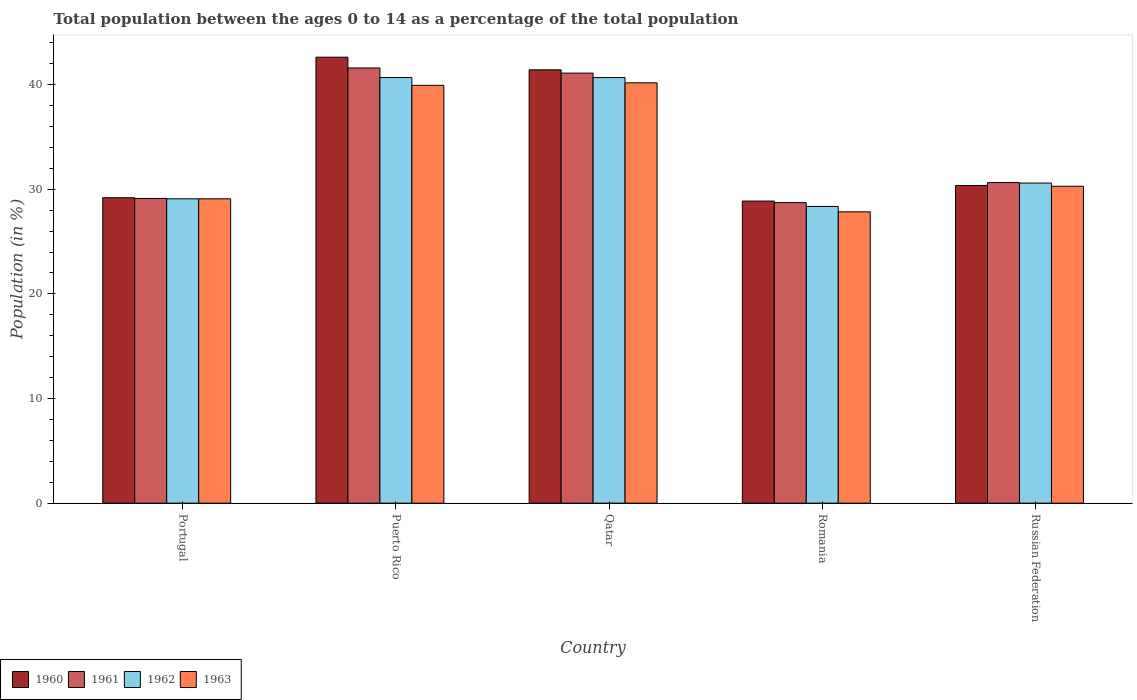How many different coloured bars are there?
Make the answer very short. 4. How many groups of bars are there?
Give a very brief answer. 5. Are the number of bars per tick equal to the number of legend labels?
Offer a very short reply. Yes. Are the number of bars on each tick of the X-axis equal?
Your answer should be very brief. Yes. What is the label of the 3rd group of bars from the left?
Keep it short and to the point. Qatar. In how many cases, is the number of bars for a given country not equal to the number of legend labels?
Offer a terse response. 0. What is the percentage of the population ages 0 to 14 in 1963 in Portugal?
Your answer should be compact. 29.09. Across all countries, what is the maximum percentage of the population ages 0 to 14 in 1961?
Your answer should be compact. 41.6. Across all countries, what is the minimum percentage of the population ages 0 to 14 in 1962?
Your response must be concise. 28.36. In which country was the percentage of the population ages 0 to 14 in 1960 maximum?
Offer a very short reply. Puerto Rico. In which country was the percentage of the population ages 0 to 14 in 1960 minimum?
Provide a short and direct response. Romania. What is the total percentage of the population ages 0 to 14 in 1963 in the graph?
Give a very brief answer. 167.35. What is the difference between the percentage of the population ages 0 to 14 in 1961 in Qatar and that in Romania?
Offer a very short reply. 12.38. What is the difference between the percentage of the population ages 0 to 14 in 1960 in Puerto Rico and the percentage of the population ages 0 to 14 in 1963 in Russian Federation?
Offer a very short reply. 12.34. What is the average percentage of the population ages 0 to 14 in 1961 per country?
Your answer should be very brief. 34.24. What is the difference between the percentage of the population ages 0 to 14 of/in 1963 and percentage of the population ages 0 to 14 of/in 1962 in Romania?
Provide a succinct answer. -0.51. In how many countries, is the percentage of the population ages 0 to 14 in 1963 greater than 28?
Ensure brevity in your answer.  4. What is the ratio of the percentage of the population ages 0 to 14 in 1961 in Puerto Rico to that in Russian Federation?
Ensure brevity in your answer.  1.36. Is the percentage of the population ages 0 to 14 in 1961 in Puerto Rico less than that in Russian Federation?
Your answer should be compact. No. Is the difference between the percentage of the population ages 0 to 14 in 1963 in Portugal and Qatar greater than the difference between the percentage of the population ages 0 to 14 in 1962 in Portugal and Qatar?
Provide a succinct answer. Yes. What is the difference between the highest and the second highest percentage of the population ages 0 to 14 in 1963?
Make the answer very short. 9.89. What is the difference between the highest and the lowest percentage of the population ages 0 to 14 in 1960?
Keep it short and to the point. 13.76. In how many countries, is the percentage of the population ages 0 to 14 in 1962 greater than the average percentage of the population ages 0 to 14 in 1962 taken over all countries?
Make the answer very short. 2. Is it the case that in every country, the sum of the percentage of the population ages 0 to 14 in 1960 and percentage of the population ages 0 to 14 in 1962 is greater than the sum of percentage of the population ages 0 to 14 in 1961 and percentage of the population ages 0 to 14 in 1963?
Your response must be concise. No. What does the 1st bar from the left in Portugal represents?
Your answer should be very brief. 1960. What does the 3rd bar from the right in Romania represents?
Offer a very short reply. 1961. Is it the case that in every country, the sum of the percentage of the population ages 0 to 14 in 1962 and percentage of the population ages 0 to 14 in 1963 is greater than the percentage of the population ages 0 to 14 in 1961?
Provide a short and direct response. Yes. Are all the bars in the graph horizontal?
Keep it short and to the point. No. How many countries are there in the graph?
Your answer should be very brief. 5. Does the graph contain any zero values?
Your answer should be very brief. No. Does the graph contain grids?
Your answer should be very brief. No. Where does the legend appear in the graph?
Your answer should be compact. Bottom left. How are the legend labels stacked?
Make the answer very short. Horizontal. What is the title of the graph?
Make the answer very short. Total population between the ages 0 to 14 as a percentage of the total population. Does "1982" appear as one of the legend labels in the graph?
Offer a very short reply. No. What is the label or title of the Y-axis?
Ensure brevity in your answer.  Population (in %). What is the Population (in %) in 1960 in Portugal?
Offer a very short reply. 29.19. What is the Population (in %) in 1961 in Portugal?
Give a very brief answer. 29.13. What is the Population (in %) in 1962 in Portugal?
Keep it short and to the point. 29.09. What is the Population (in %) of 1963 in Portugal?
Provide a short and direct response. 29.09. What is the Population (in %) of 1960 in Puerto Rico?
Your answer should be very brief. 42.63. What is the Population (in %) of 1961 in Puerto Rico?
Your response must be concise. 41.6. What is the Population (in %) of 1962 in Puerto Rico?
Offer a terse response. 40.69. What is the Population (in %) in 1963 in Puerto Rico?
Your answer should be very brief. 39.94. What is the Population (in %) of 1960 in Qatar?
Make the answer very short. 41.42. What is the Population (in %) in 1961 in Qatar?
Provide a succinct answer. 41.11. What is the Population (in %) of 1962 in Qatar?
Make the answer very short. 40.68. What is the Population (in %) of 1963 in Qatar?
Make the answer very short. 40.18. What is the Population (in %) in 1960 in Romania?
Offer a very short reply. 28.88. What is the Population (in %) of 1961 in Romania?
Offer a very short reply. 28.73. What is the Population (in %) in 1962 in Romania?
Your answer should be compact. 28.36. What is the Population (in %) in 1963 in Romania?
Your answer should be compact. 27.85. What is the Population (in %) of 1960 in Russian Federation?
Give a very brief answer. 30.37. What is the Population (in %) of 1961 in Russian Federation?
Your response must be concise. 30.64. What is the Population (in %) in 1962 in Russian Federation?
Keep it short and to the point. 30.6. What is the Population (in %) in 1963 in Russian Federation?
Provide a succinct answer. 30.29. Across all countries, what is the maximum Population (in %) in 1960?
Offer a terse response. 42.63. Across all countries, what is the maximum Population (in %) of 1961?
Your answer should be compact. 41.6. Across all countries, what is the maximum Population (in %) in 1962?
Give a very brief answer. 40.69. Across all countries, what is the maximum Population (in %) in 1963?
Your answer should be compact. 40.18. Across all countries, what is the minimum Population (in %) of 1960?
Keep it short and to the point. 28.88. Across all countries, what is the minimum Population (in %) of 1961?
Ensure brevity in your answer.  28.73. Across all countries, what is the minimum Population (in %) in 1962?
Provide a short and direct response. 28.36. Across all countries, what is the minimum Population (in %) in 1963?
Ensure brevity in your answer.  27.85. What is the total Population (in %) of 1960 in the graph?
Make the answer very short. 172.48. What is the total Population (in %) of 1961 in the graph?
Your response must be concise. 171.2. What is the total Population (in %) in 1962 in the graph?
Give a very brief answer. 169.42. What is the total Population (in %) of 1963 in the graph?
Provide a succinct answer. 167.35. What is the difference between the Population (in %) in 1960 in Portugal and that in Puerto Rico?
Your answer should be very brief. -13.44. What is the difference between the Population (in %) in 1961 in Portugal and that in Puerto Rico?
Your answer should be compact. -12.47. What is the difference between the Population (in %) of 1962 in Portugal and that in Puerto Rico?
Your response must be concise. -11.59. What is the difference between the Population (in %) in 1963 in Portugal and that in Puerto Rico?
Offer a terse response. -10.85. What is the difference between the Population (in %) of 1960 in Portugal and that in Qatar?
Your response must be concise. -12.23. What is the difference between the Population (in %) in 1961 in Portugal and that in Qatar?
Make the answer very short. -11.98. What is the difference between the Population (in %) of 1962 in Portugal and that in Qatar?
Your response must be concise. -11.59. What is the difference between the Population (in %) of 1963 in Portugal and that in Qatar?
Your response must be concise. -11.09. What is the difference between the Population (in %) in 1960 in Portugal and that in Romania?
Your response must be concise. 0.32. What is the difference between the Population (in %) in 1961 in Portugal and that in Romania?
Provide a short and direct response. 0.4. What is the difference between the Population (in %) of 1962 in Portugal and that in Romania?
Your answer should be compact. 0.73. What is the difference between the Population (in %) of 1963 in Portugal and that in Romania?
Your answer should be very brief. 1.25. What is the difference between the Population (in %) in 1960 in Portugal and that in Russian Federation?
Your answer should be very brief. -1.17. What is the difference between the Population (in %) of 1961 in Portugal and that in Russian Federation?
Offer a terse response. -1.52. What is the difference between the Population (in %) in 1962 in Portugal and that in Russian Federation?
Make the answer very short. -1.5. What is the difference between the Population (in %) in 1963 in Portugal and that in Russian Federation?
Provide a short and direct response. -1.2. What is the difference between the Population (in %) of 1960 in Puerto Rico and that in Qatar?
Your answer should be compact. 1.21. What is the difference between the Population (in %) of 1961 in Puerto Rico and that in Qatar?
Keep it short and to the point. 0.49. What is the difference between the Population (in %) in 1962 in Puerto Rico and that in Qatar?
Your response must be concise. 0.01. What is the difference between the Population (in %) in 1963 in Puerto Rico and that in Qatar?
Offer a very short reply. -0.24. What is the difference between the Population (in %) of 1960 in Puerto Rico and that in Romania?
Keep it short and to the point. 13.76. What is the difference between the Population (in %) of 1961 in Puerto Rico and that in Romania?
Your response must be concise. 12.87. What is the difference between the Population (in %) of 1962 in Puerto Rico and that in Romania?
Provide a short and direct response. 12.33. What is the difference between the Population (in %) of 1963 in Puerto Rico and that in Romania?
Your response must be concise. 12.09. What is the difference between the Population (in %) in 1960 in Puerto Rico and that in Russian Federation?
Your response must be concise. 12.26. What is the difference between the Population (in %) of 1961 in Puerto Rico and that in Russian Federation?
Keep it short and to the point. 10.96. What is the difference between the Population (in %) of 1962 in Puerto Rico and that in Russian Federation?
Provide a short and direct response. 10.09. What is the difference between the Population (in %) of 1963 in Puerto Rico and that in Russian Federation?
Make the answer very short. 9.65. What is the difference between the Population (in %) in 1960 in Qatar and that in Romania?
Offer a terse response. 12.54. What is the difference between the Population (in %) of 1961 in Qatar and that in Romania?
Offer a terse response. 12.38. What is the difference between the Population (in %) of 1962 in Qatar and that in Romania?
Provide a short and direct response. 12.32. What is the difference between the Population (in %) of 1963 in Qatar and that in Romania?
Give a very brief answer. 12.33. What is the difference between the Population (in %) in 1960 in Qatar and that in Russian Federation?
Give a very brief answer. 11.05. What is the difference between the Population (in %) in 1961 in Qatar and that in Russian Federation?
Provide a succinct answer. 10.46. What is the difference between the Population (in %) of 1962 in Qatar and that in Russian Federation?
Ensure brevity in your answer.  10.09. What is the difference between the Population (in %) in 1963 in Qatar and that in Russian Federation?
Make the answer very short. 9.89. What is the difference between the Population (in %) in 1960 in Romania and that in Russian Federation?
Keep it short and to the point. -1.49. What is the difference between the Population (in %) of 1961 in Romania and that in Russian Federation?
Your response must be concise. -1.92. What is the difference between the Population (in %) in 1962 in Romania and that in Russian Federation?
Your answer should be very brief. -2.24. What is the difference between the Population (in %) of 1963 in Romania and that in Russian Federation?
Your answer should be very brief. -2.44. What is the difference between the Population (in %) in 1960 in Portugal and the Population (in %) in 1961 in Puerto Rico?
Provide a succinct answer. -12.41. What is the difference between the Population (in %) in 1960 in Portugal and the Population (in %) in 1962 in Puerto Rico?
Keep it short and to the point. -11.5. What is the difference between the Population (in %) of 1960 in Portugal and the Population (in %) of 1963 in Puerto Rico?
Your response must be concise. -10.75. What is the difference between the Population (in %) in 1961 in Portugal and the Population (in %) in 1962 in Puerto Rico?
Provide a succinct answer. -11.56. What is the difference between the Population (in %) in 1961 in Portugal and the Population (in %) in 1963 in Puerto Rico?
Provide a succinct answer. -10.81. What is the difference between the Population (in %) of 1962 in Portugal and the Population (in %) of 1963 in Puerto Rico?
Keep it short and to the point. -10.85. What is the difference between the Population (in %) in 1960 in Portugal and the Population (in %) in 1961 in Qatar?
Give a very brief answer. -11.91. What is the difference between the Population (in %) in 1960 in Portugal and the Population (in %) in 1962 in Qatar?
Offer a very short reply. -11.49. What is the difference between the Population (in %) in 1960 in Portugal and the Population (in %) in 1963 in Qatar?
Your response must be concise. -10.99. What is the difference between the Population (in %) in 1961 in Portugal and the Population (in %) in 1962 in Qatar?
Your answer should be very brief. -11.56. What is the difference between the Population (in %) in 1961 in Portugal and the Population (in %) in 1963 in Qatar?
Provide a succinct answer. -11.05. What is the difference between the Population (in %) of 1962 in Portugal and the Population (in %) of 1963 in Qatar?
Provide a short and direct response. -11.09. What is the difference between the Population (in %) in 1960 in Portugal and the Population (in %) in 1961 in Romania?
Offer a terse response. 0.47. What is the difference between the Population (in %) of 1960 in Portugal and the Population (in %) of 1962 in Romania?
Provide a succinct answer. 0.83. What is the difference between the Population (in %) of 1960 in Portugal and the Population (in %) of 1963 in Romania?
Provide a succinct answer. 1.34. What is the difference between the Population (in %) of 1961 in Portugal and the Population (in %) of 1962 in Romania?
Your answer should be compact. 0.76. What is the difference between the Population (in %) in 1961 in Portugal and the Population (in %) in 1963 in Romania?
Provide a succinct answer. 1.28. What is the difference between the Population (in %) of 1962 in Portugal and the Population (in %) of 1963 in Romania?
Your answer should be very brief. 1.25. What is the difference between the Population (in %) of 1960 in Portugal and the Population (in %) of 1961 in Russian Federation?
Offer a very short reply. -1.45. What is the difference between the Population (in %) in 1960 in Portugal and the Population (in %) in 1962 in Russian Federation?
Ensure brevity in your answer.  -1.4. What is the difference between the Population (in %) in 1960 in Portugal and the Population (in %) in 1963 in Russian Federation?
Your response must be concise. -1.1. What is the difference between the Population (in %) in 1961 in Portugal and the Population (in %) in 1962 in Russian Federation?
Your answer should be compact. -1.47. What is the difference between the Population (in %) of 1961 in Portugal and the Population (in %) of 1963 in Russian Federation?
Ensure brevity in your answer.  -1.17. What is the difference between the Population (in %) in 1962 in Portugal and the Population (in %) in 1963 in Russian Federation?
Make the answer very short. -1.2. What is the difference between the Population (in %) in 1960 in Puerto Rico and the Population (in %) in 1961 in Qatar?
Give a very brief answer. 1.52. What is the difference between the Population (in %) of 1960 in Puerto Rico and the Population (in %) of 1962 in Qatar?
Provide a succinct answer. 1.95. What is the difference between the Population (in %) of 1960 in Puerto Rico and the Population (in %) of 1963 in Qatar?
Ensure brevity in your answer.  2.45. What is the difference between the Population (in %) in 1961 in Puerto Rico and the Population (in %) in 1962 in Qatar?
Give a very brief answer. 0.92. What is the difference between the Population (in %) in 1961 in Puerto Rico and the Population (in %) in 1963 in Qatar?
Provide a short and direct response. 1.42. What is the difference between the Population (in %) of 1962 in Puerto Rico and the Population (in %) of 1963 in Qatar?
Keep it short and to the point. 0.51. What is the difference between the Population (in %) in 1960 in Puerto Rico and the Population (in %) in 1961 in Romania?
Offer a terse response. 13.9. What is the difference between the Population (in %) in 1960 in Puerto Rico and the Population (in %) in 1962 in Romania?
Keep it short and to the point. 14.27. What is the difference between the Population (in %) of 1960 in Puerto Rico and the Population (in %) of 1963 in Romania?
Provide a succinct answer. 14.78. What is the difference between the Population (in %) in 1961 in Puerto Rico and the Population (in %) in 1962 in Romania?
Your response must be concise. 13.24. What is the difference between the Population (in %) of 1961 in Puerto Rico and the Population (in %) of 1963 in Romania?
Your response must be concise. 13.75. What is the difference between the Population (in %) in 1962 in Puerto Rico and the Population (in %) in 1963 in Romania?
Keep it short and to the point. 12.84. What is the difference between the Population (in %) of 1960 in Puerto Rico and the Population (in %) of 1961 in Russian Federation?
Your response must be concise. 11.99. What is the difference between the Population (in %) in 1960 in Puerto Rico and the Population (in %) in 1962 in Russian Federation?
Provide a short and direct response. 12.03. What is the difference between the Population (in %) of 1960 in Puerto Rico and the Population (in %) of 1963 in Russian Federation?
Make the answer very short. 12.34. What is the difference between the Population (in %) in 1961 in Puerto Rico and the Population (in %) in 1962 in Russian Federation?
Offer a very short reply. 11. What is the difference between the Population (in %) of 1961 in Puerto Rico and the Population (in %) of 1963 in Russian Federation?
Provide a short and direct response. 11.31. What is the difference between the Population (in %) in 1962 in Puerto Rico and the Population (in %) in 1963 in Russian Federation?
Offer a very short reply. 10.4. What is the difference between the Population (in %) in 1960 in Qatar and the Population (in %) in 1961 in Romania?
Provide a succinct answer. 12.69. What is the difference between the Population (in %) in 1960 in Qatar and the Population (in %) in 1962 in Romania?
Your answer should be very brief. 13.06. What is the difference between the Population (in %) of 1960 in Qatar and the Population (in %) of 1963 in Romania?
Offer a very short reply. 13.57. What is the difference between the Population (in %) in 1961 in Qatar and the Population (in %) in 1962 in Romania?
Your answer should be compact. 12.74. What is the difference between the Population (in %) of 1961 in Qatar and the Population (in %) of 1963 in Romania?
Keep it short and to the point. 13.26. What is the difference between the Population (in %) of 1962 in Qatar and the Population (in %) of 1963 in Romania?
Offer a terse response. 12.83. What is the difference between the Population (in %) in 1960 in Qatar and the Population (in %) in 1961 in Russian Federation?
Your answer should be compact. 10.78. What is the difference between the Population (in %) of 1960 in Qatar and the Population (in %) of 1962 in Russian Federation?
Your response must be concise. 10.82. What is the difference between the Population (in %) in 1960 in Qatar and the Population (in %) in 1963 in Russian Federation?
Keep it short and to the point. 11.13. What is the difference between the Population (in %) in 1961 in Qatar and the Population (in %) in 1962 in Russian Federation?
Provide a short and direct response. 10.51. What is the difference between the Population (in %) in 1961 in Qatar and the Population (in %) in 1963 in Russian Federation?
Make the answer very short. 10.81. What is the difference between the Population (in %) of 1962 in Qatar and the Population (in %) of 1963 in Russian Federation?
Give a very brief answer. 10.39. What is the difference between the Population (in %) of 1960 in Romania and the Population (in %) of 1961 in Russian Federation?
Make the answer very short. -1.77. What is the difference between the Population (in %) in 1960 in Romania and the Population (in %) in 1962 in Russian Federation?
Give a very brief answer. -1.72. What is the difference between the Population (in %) in 1960 in Romania and the Population (in %) in 1963 in Russian Federation?
Your answer should be compact. -1.42. What is the difference between the Population (in %) in 1961 in Romania and the Population (in %) in 1962 in Russian Federation?
Your answer should be compact. -1.87. What is the difference between the Population (in %) of 1961 in Romania and the Population (in %) of 1963 in Russian Federation?
Your answer should be compact. -1.57. What is the difference between the Population (in %) in 1962 in Romania and the Population (in %) in 1963 in Russian Federation?
Offer a terse response. -1.93. What is the average Population (in %) in 1960 per country?
Keep it short and to the point. 34.5. What is the average Population (in %) in 1961 per country?
Offer a very short reply. 34.24. What is the average Population (in %) of 1962 per country?
Your answer should be compact. 33.88. What is the average Population (in %) of 1963 per country?
Your answer should be very brief. 33.47. What is the difference between the Population (in %) in 1960 and Population (in %) in 1961 in Portugal?
Your response must be concise. 0.07. What is the difference between the Population (in %) in 1960 and Population (in %) in 1962 in Portugal?
Provide a succinct answer. 0.1. What is the difference between the Population (in %) in 1960 and Population (in %) in 1963 in Portugal?
Your response must be concise. 0.1. What is the difference between the Population (in %) in 1961 and Population (in %) in 1962 in Portugal?
Your answer should be very brief. 0.03. What is the difference between the Population (in %) in 1961 and Population (in %) in 1963 in Portugal?
Provide a short and direct response. 0.03. What is the difference between the Population (in %) of 1962 and Population (in %) of 1963 in Portugal?
Give a very brief answer. 0. What is the difference between the Population (in %) in 1960 and Population (in %) in 1961 in Puerto Rico?
Your answer should be very brief. 1.03. What is the difference between the Population (in %) in 1960 and Population (in %) in 1962 in Puerto Rico?
Your answer should be very brief. 1.94. What is the difference between the Population (in %) of 1960 and Population (in %) of 1963 in Puerto Rico?
Keep it short and to the point. 2.69. What is the difference between the Population (in %) of 1961 and Population (in %) of 1962 in Puerto Rico?
Provide a succinct answer. 0.91. What is the difference between the Population (in %) in 1961 and Population (in %) in 1963 in Puerto Rico?
Your answer should be very brief. 1.66. What is the difference between the Population (in %) of 1962 and Population (in %) of 1963 in Puerto Rico?
Make the answer very short. 0.75. What is the difference between the Population (in %) of 1960 and Population (in %) of 1961 in Qatar?
Your answer should be compact. 0.31. What is the difference between the Population (in %) of 1960 and Population (in %) of 1962 in Qatar?
Provide a succinct answer. 0.74. What is the difference between the Population (in %) in 1960 and Population (in %) in 1963 in Qatar?
Ensure brevity in your answer.  1.24. What is the difference between the Population (in %) of 1961 and Population (in %) of 1962 in Qatar?
Offer a terse response. 0.42. What is the difference between the Population (in %) of 1961 and Population (in %) of 1963 in Qatar?
Your response must be concise. 0.93. What is the difference between the Population (in %) of 1962 and Population (in %) of 1963 in Qatar?
Keep it short and to the point. 0.5. What is the difference between the Population (in %) of 1960 and Population (in %) of 1961 in Romania?
Offer a very short reply. 0.15. What is the difference between the Population (in %) of 1960 and Population (in %) of 1962 in Romania?
Make the answer very short. 0.51. What is the difference between the Population (in %) of 1960 and Population (in %) of 1963 in Romania?
Give a very brief answer. 1.03. What is the difference between the Population (in %) in 1961 and Population (in %) in 1962 in Romania?
Your response must be concise. 0.36. What is the difference between the Population (in %) in 1961 and Population (in %) in 1963 in Romania?
Provide a succinct answer. 0.88. What is the difference between the Population (in %) in 1962 and Population (in %) in 1963 in Romania?
Your answer should be compact. 0.51. What is the difference between the Population (in %) of 1960 and Population (in %) of 1961 in Russian Federation?
Provide a short and direct response. -0.28. What is the difference between the Population (in %) of 1960 and Population (in %) of 1962 in Russian Federation?
Give a very brief answer. -0.23. What is the difference between the Population (in %) of 1960 and Population (in %) of 1963 in Russian Federation?
Your response must be concise. 0.07. What is the difference between the Population (in %) of 1961 and Population (in %) of 1962 in Russian Federation?
Ensure brevity in your answer.  0.04. What is the difference between the Population (in %) in 1961 and Population (in %) in 1963 in Russian Federation?
Make the answer very short. 0.35. What is the difference between the Population (in %) of 1962 and Population (in %) of 1963 in Russian Federation?
Offer a terse response. 0.3. What is the ratio of the Population (in %) in 1960 in Portugal to that in Puerto Rico?
Keep it short and to the point. 0.68. What is the ratio of the Population (in %) of 1961 in Portugal to that in Puerto Rico?
Keep it short and to the point. 0.7. What is the ratio of the Population (in %) of 1962 in Portugal to that in Puerto Rico?
Offer a very short reply. 0.71. What is the ratio of the Population (in %) in 1963 in Portugal to that in Puerto Rico?
Offer a terse response. 0.73. What is the ratio of the Population (in %) in 1960 in Portugal to that in Qatar?
Offer a terse response. 0.7. What is the ratio of the Population (in %) of 1961 in Portugal to that in Qatar?
Offer a very short reply. 0.71. What is the ratio of the Population (in %) of 1962 in Portugal to that in Qatar?
Keep it short and to the point. 0.72. What is the ratio of the Population (in %) of 1963 in Portugal to that in Qatar?
Your answer should be very brief. 0.72. What is the ratio of the Population (in %) in 1961 in Portugal to that in Romania?
Provide a succinct answer. 1.01. What is the ratio of the Population (in %) of 1962 in Portugal to that in Romania?
Ensure brevity in your answer.  1.03. What is the ratio of the Population (in %) in 1963 in Portugal to that in Romania?
Provide a succinct answer. 1.04. What is the ratio of the Population (in %) of 1960 in Portugal to that in Russian Federation?
Provide a short and direct response. 0.96. What is the ratio of the Population (in %) of 1961 in Portugal to that in Russian Federation?
Your response must be concise. 0.95. What is the ratio of the Population (in %) in 1962 in Portugal to that in Russian Federation?
Your answer should be compact. 0.95. What is the ratio of the Population (in %) in 1963 in Portugal to that in Russian Federation?
Ensure brevity in your answer.  0.96. What is the ratio of the Population (in %) in 1960 in Puerto Rico to that in Qatar?
Your response must be concise. 1.03. What is the ratio of the Population (in %) of 1960 in Puerto Rico to that in Romania?
Give a very brief answer. 1.48. What is the ratio of the Population (in %) in 1961 in Puerto Rico to that in Romania?
Ensure brevity in your answer.  1.45. What is the ratio of the Population (in %) of 1962 in Puerto Rico to that in Romania?
Provide a short and direct response. 1.43. What is the ratio of the Population (in %) of 1963 in Puerto Rico to that in Romania?
Keep it short and to the point. 1.43. What is the ratio of the Population (in %) of 1960 in Puerto Rico to that in Russian Federation?
Your answer should be compact. 1.4. What is the ratio of the Population (in %) in 1961 in Puerto Rico to that in Russian Federation?
Ensure brevity in your answer.  1.36. What is the ratio of the Population (in %) in 1962 in Puerto Rico to that in Russian Federation?
Give a very brief answer. 1.33. What is the ratio of the Population (in %) of 1963 in Puerto Rico to that in Russian Federation?
Offer a very short reply. 1.32. What is the ratio of the Population (in %) in 1960 in Qatar to that in Romania?
Ensure brevity in your answer.  1.43. What is the ratio of the Population (in %) of 1961 in Qatar to that in Romania?
Offer a very short reply. 1.43. What is the ratio of the Population (in %) of 1962 in Qatar to that in Romania?
Provide a succinct answer. 1.43. What is the ratio of the Population (in %) in 1963 in Qatar to that in Romania?
Keep it short and to the point. 1.44. What is the ratio of the Population (in %) in 1960 in Qatar to that in Russian Federation?
Your response must be concise. 1.36. What is the ratio of the Population (in %) in 1961 in Qatar to that in Russian Federation?
Ensure brevity in your answer.  1.34. What is the ratio of the Population (in %) of 1962 in Qatar to that in Russian Federation?
Provide a short and direct response. 1.33. What is the ratio of the Population (in %) in 1963 in Qatar to that in Russian Federation?
Keep it short and to the point. 1.33. What is the ratio of the Population (in %) of 1960 in Romania to that in Russian Federation?
Make the answer very short. 0.95. What is the ratio of the Population (in %) in 1961 in Romania to that in Russian Federation?
Give a very brief answer. 0.94. What is the ratio of the Population (in %) of 1962 in Romania to that in Russian Federation?
Provide a short and direct response. 0.93. What is the ratio of the Population (in %) in 1963 in Romania to that in Russian Federation?
Give a very brief answer. 0.92. What is the difference between the highest and the second highest Population (in %) of 1960?
Offer a terse response. 1.21. What is the difference between the highest and the second highest Population (in %) in 1961?
Your response must be concise. 0.49. What is the difference between the highest and the second highest Population (in %) in 1962?
Keep it short and to the point. 0.01. What is the difference between the highest and the second highest Population (in %) in 1963?
Give a very brief answer. 0.24. What is the difference between the highest and the lowest Population (in %) of 1960?
Keep it short and to the point. 13.76. What is the difference between the highest and the lowest Population (in %) in 1961?
Keep it short and to the point. 12.87. What is the difference between the highest and the lowest Population (in %) in 1962?
Your answer should be compact. 12.33. What is the difference between the highest and the lowest Population (in %) of 1963?
Give a very brief answer. 12.33. 